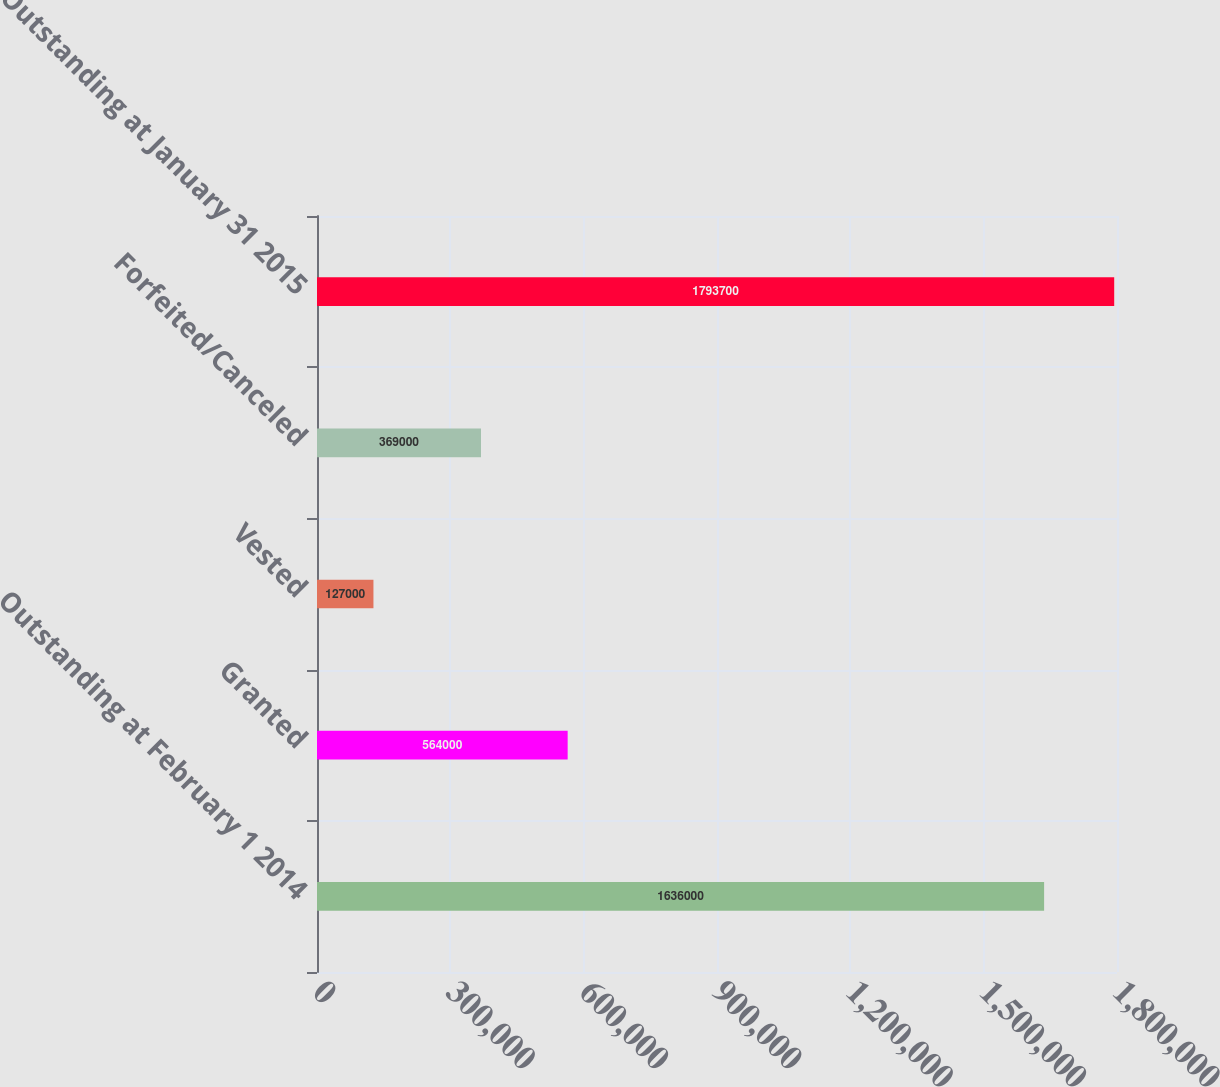<chart> <loc_0><loc_0><loc_500><loc_500><bar_chart><fcel>Outstanding at February 1 2014<fcel>Granted<fcel>Vested<fcel>Forfeited/Canceled<fcel>Outstanding at January 31 2015<nl><fcel>1.636e+06<fcel>564000<fcel>127000<fcel>369000<fcel>1.7937e+06<nl></chart> 